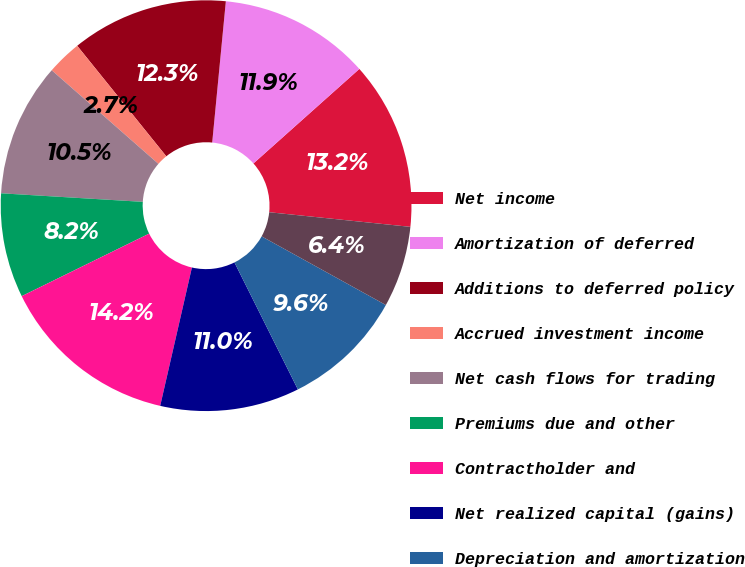<chart> <loc_0><loc_0><loc_500><loc_500><pie_chart><fcel>Net income<fcel>Amortization of deferred<fcel>Additions to deferred policy<fcel>Accrued investment income<fcel>Net cash flows for trading<fcel>Premiums due and other<fcel>Contractholder and<fcel>Net realized capital (gains)<fcel>Depreciation and amortization<fcel>Mortgage loans held for sale<nl><fcel>13.24%<fcel>11.87%<fcel>12.33%<fcel>2.74%<fcel>10.5%<fcel>8.22%<fcel>14.15%<fcel>10.96%<fcel>9.59%<fcel>6.39%<nl></chart> 